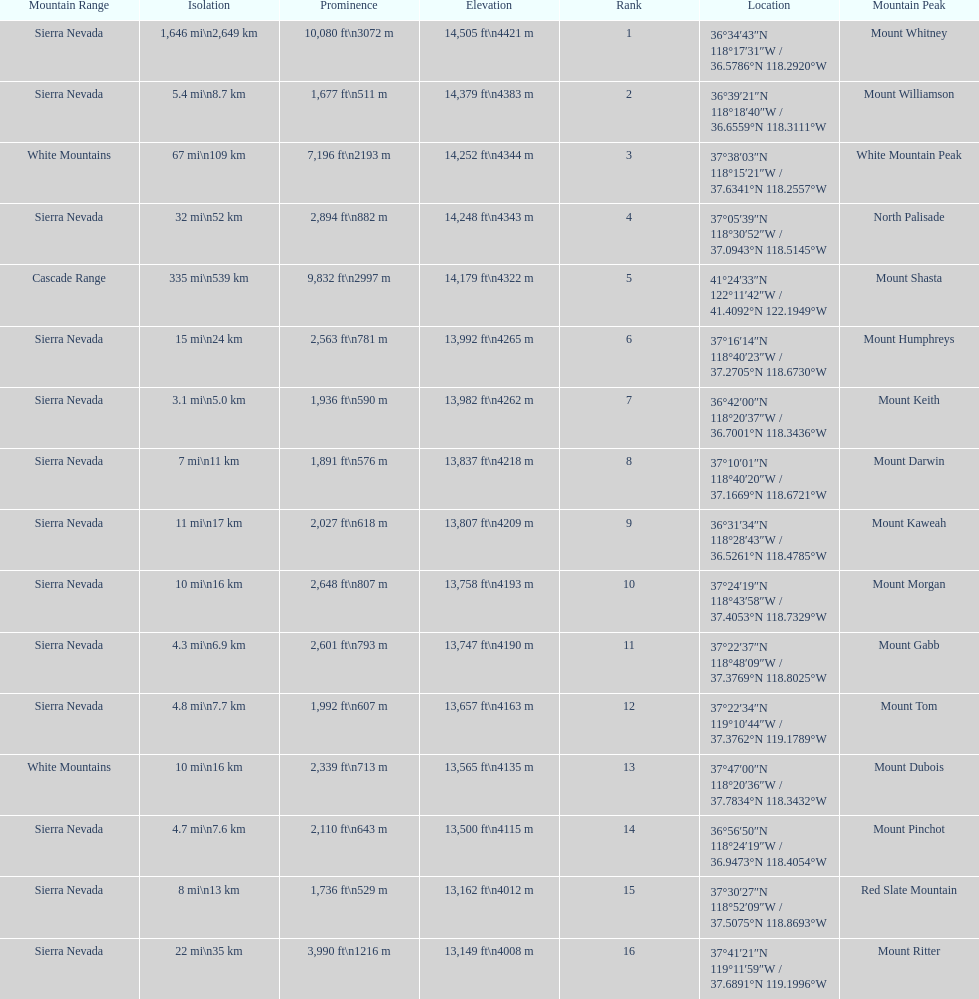Which mountain peak is no higher than 13,149 ft? Mount Ritter. 